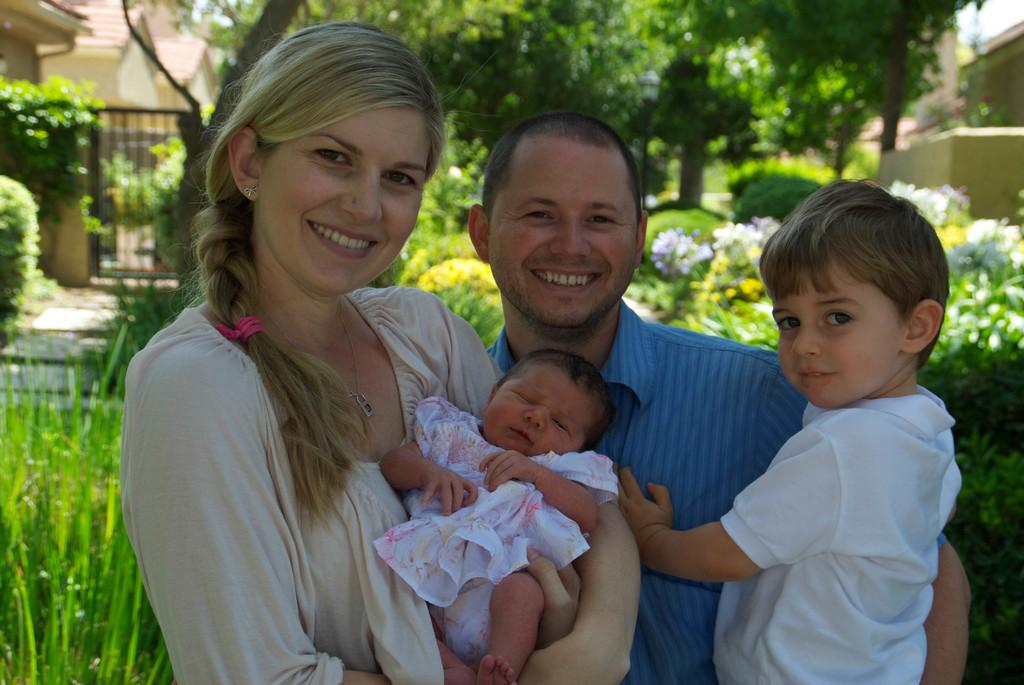What can be seen in the foreground of the image? There are people standing in the front of the image. What type of vegetation is present in the image? There is grass, plants, flowers, and trees in the image. What architectural feature can be seen in the image? There is a gate in the image. What type of structures are visible in the background of the image? There are buildings in the image. What is the purpose of the waves in the image? There are no waves present in the image. How does the image turn into a different scene? The image does not turn into a different scene; it remains the same as described in the facts. 